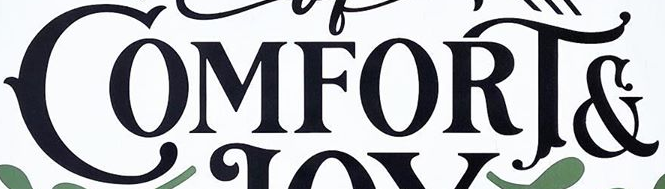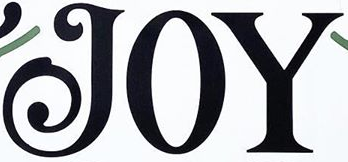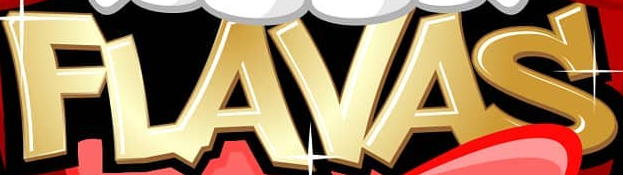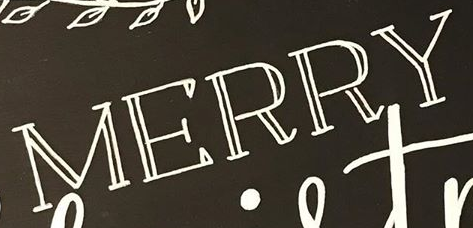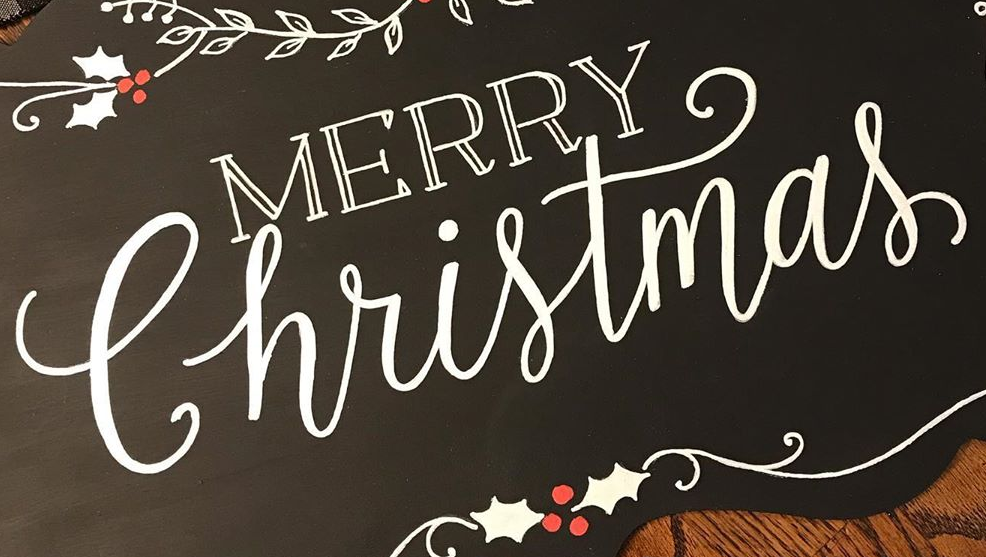What words are shown in these images in order, separated by a semicolon? COMFORT&; JOY; FLAVAS; MERRY; Christmas 